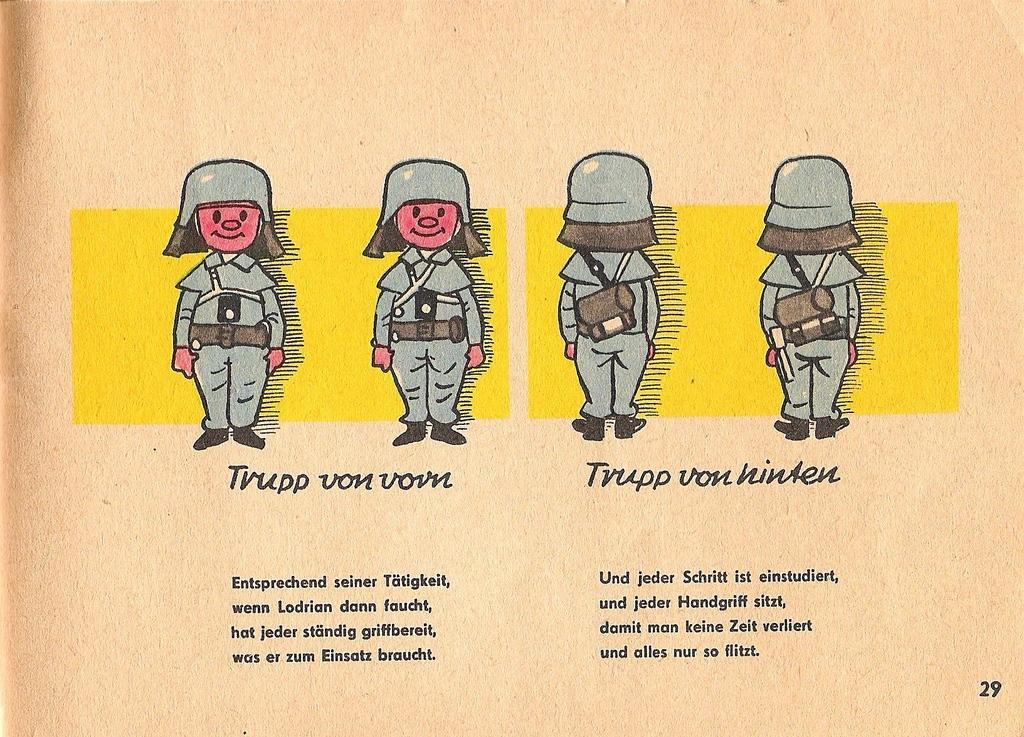What type of visual content is present in the image? There are cartoons in the image. Are there any written words in the image? Yes, there is text in the image. What type of board is being used to treat the disease in the image? There is no board or disease present in the image; it only contains cartoons and text. 